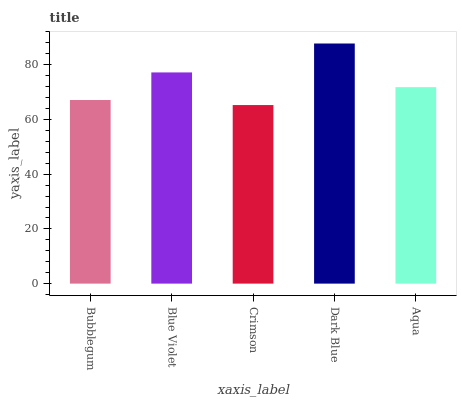Is Crimson the minimum?
Answer yes or no. Yes. Is Dark Blue the maximum?
Answer yes or no. Yes. Is Blue Violet the minimum?
Answer yes or no. No. Is Blue Violet the maximum?
Answer yes or no. No. Is Blue Violet greater than Bubblegum?
Answer yes or no. Yes. Is Bubblegum less than Blue Violet?
Answer yes or no. Yes. Is Bubblegum greater than Blue Violet?
Answer yes or no. No. Is Blue Violet less than Bubblegum?
Answer yes or no. No. Is Aqua the high median?
Answer yes or no. Yes. Is Aqua the low median?
Answer yes or no. Yes. Is Dark Blue the high median?
Answer yes or no. No. Is Bubblegum the low median?
Answer yes or no. No. 